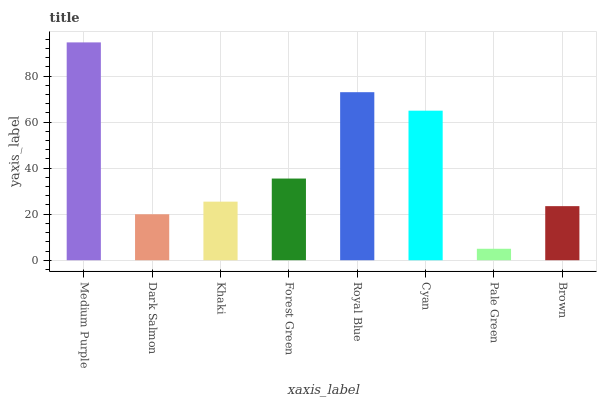Is Dark Salmon the minimum?
Answer yes or no. No. Is Dark Salmon the maximum?
Answer yes or no. No. Is Medium Purple greater than Dark Salmon?
Answer yes or no. Yes. Is Dark Salmon less than Medium Purple?
Answer yes or no. Yes. Is Dark Salmon greater than Medium Purple?
Answer yes or no. No. Is Medium Purple less than Dark Salmon?
Answer yes or no. No. Is Forest Green the high median?
Answer yes or no. Yes. Is Khaki the low median?
Answer yes or no. Yes. Is Brown the high median?
Answer yes or no. No. Is Brown the low median?
Answer yes or no. No. 